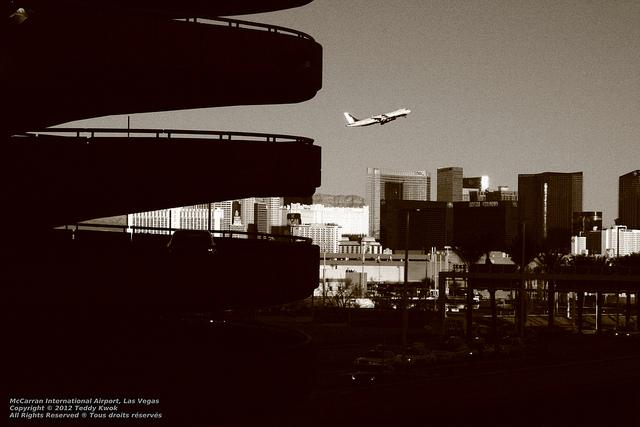What is taking off?

Choices:
A) airplane
B) balloon
C) helicopter
D) kite airplane 